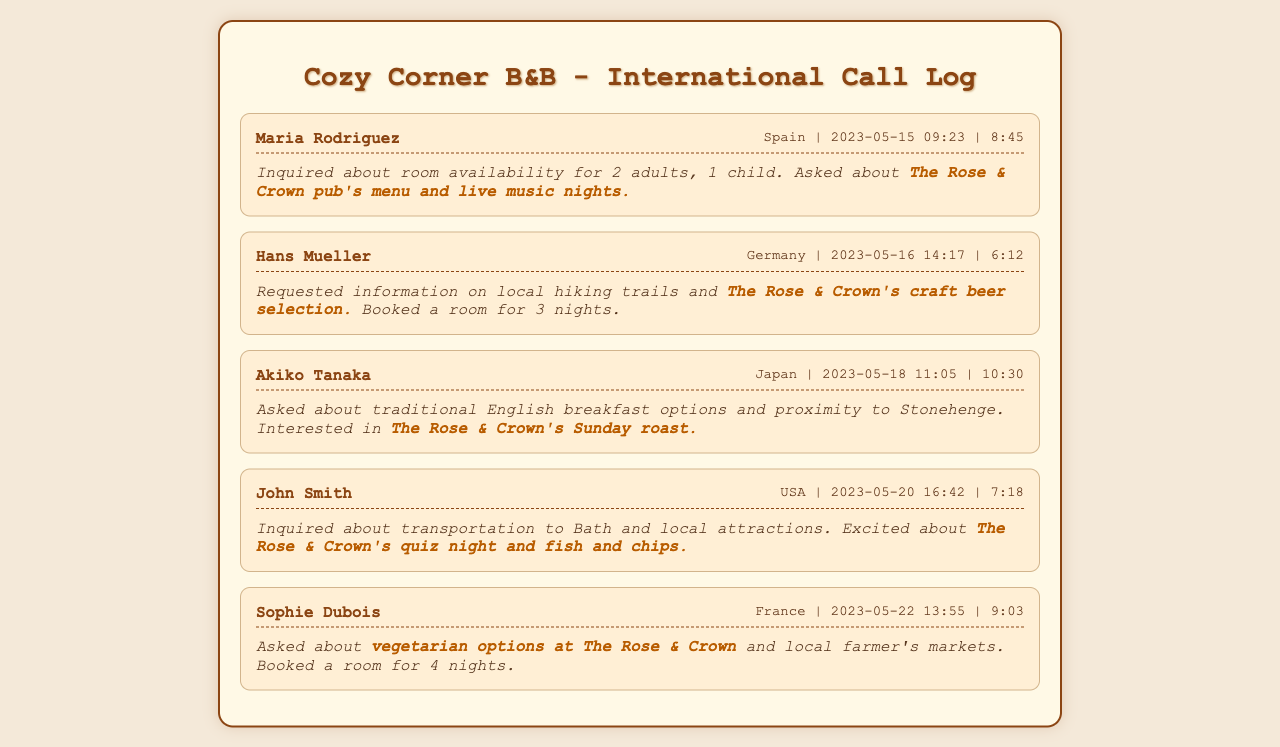What is the name of the first caller? The first caller's name is listed at the beginning of the first call record in the document.
Answer: Maria Rodriguez When did Hans Mueller make the call? The call time is shown next to the caller's name and location in the details of the call record.
Answer: 2023-05-16 14:17 How long did John Smith's call last? The duration of the call is mentioned right after the date and time in the call details.
Answer: 7:18 Which pub is frequently mentioned in the inquiries? The name of the pub is emphasized in each call record underlined by its significance to the callers.
Answer: The Rose & Crown How many nights did Sophie Dubois book a room for? The number of nights is stated in the notes section of Sophie Dubois's call record.
Answer: 4 nights What did Akiko Tanaka ask about in relation to the pub? The specific subject of inquiry regarding the pub is included in Akiko's call notes.
Answer: Sunday roast What type of options did Maria Rodriguez inquire about at The Rose & Crown? This information is detailed in the call notes where Maria asked about specific offerings at the pub.
Answer: Menu and live music nights Was any caller interested in local hiking trails? The inquiry about local hiking trails is explicitly mentioned in Hans Mueller's call record.
Answer: Yes Who inquired about transportation to Bath? The caller looking for transportation information is specified in the document.
Answer: John Smith 